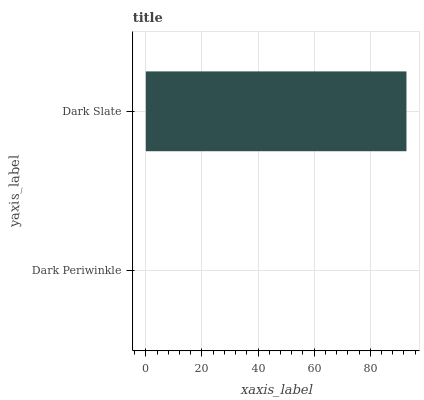Is Dark Periwinkle the minimum?
Answer yes or no. Yes. Is Dark Slate the maximum?
Answer yes or no. Yes. Is Dark Slate the minimum?
Answer yes or no. No. Is Dark Slate greater than Dark Periwinkle?
Answer yes or no. Yes. Is Dark Periwinkle less than Dark Slate?
Answer yes or no. Yes. Is Dark Periwinkle greater than Dark Slate?
Answer yes or no. No. Is Dark Slate less than Dark Periwinkle?
Answer yes or no. No. Is Dark Slate the high median?
Answer yes or no. Yes. Is Dark Periwinkle the low median?
Answer yes or no. Yes. Is Dark Periwinkle the high median?
Answer yes or no. No. Is Dark Slate the low median?
Answer yes or no. No. 